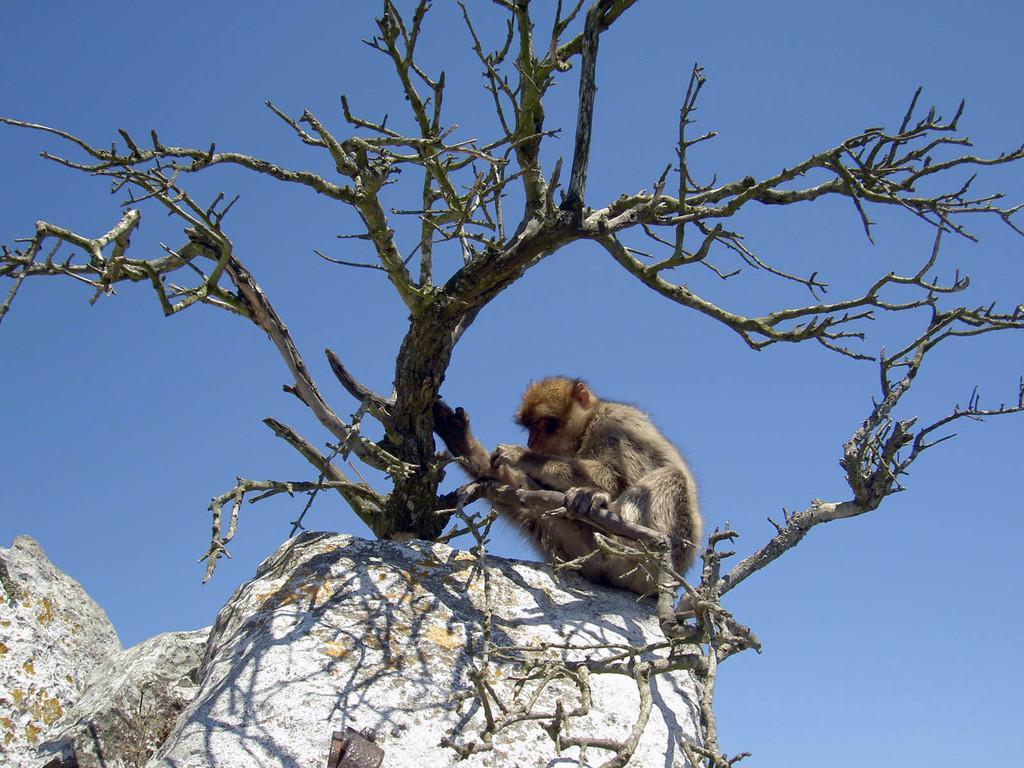Could you give a brief overview of what you see in this image? In this picture I can observe a monkey sitting on the stone in the middle of the picture. In front of the monkey there is a tree. 